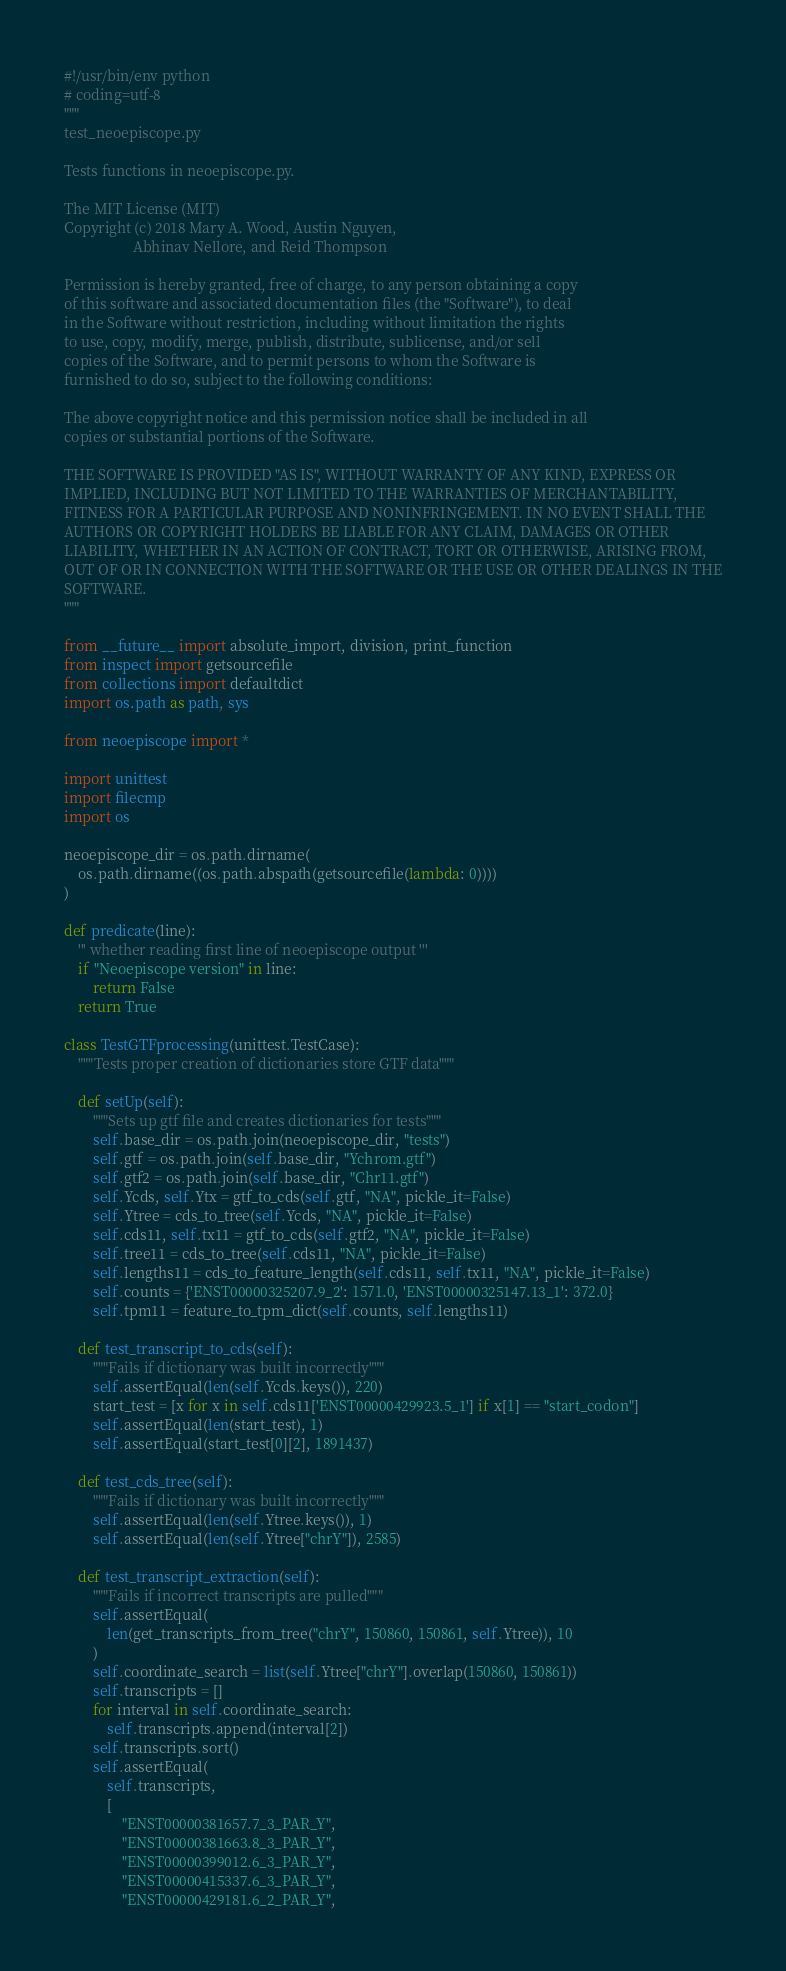Convert code to text. <code><loc_0><loc_0><loc_500><loc_500><_Python_>#!/usr/bin/env python
# coding=utf-8
"""
test_neoepiscope.py

Tests functions in neoepiscope.py.

The MIT License (MIT)
Copyright (c) 2018 Mary A. Wood, Austin Nguyen,
                   Abhinav Nellore, and Reid Thompson

Permission is hereby granted, free of charge, to any person obtaining a copy
of this software and associated documentation files (the "Software"), to deal
in the Software without restriction, including without limitation the rights
to use, copy, modify, merge, publish, distribute, sublicense, and/or sell
copies of the Software, and to permit persons to whom the Software is
furnished to do so, subject to the following conditions:

The above copyright notice and this permission notice shall be included in all
copies or substantial portions of the Software.

THE SOFTWARE IS PROVIDED "AS IS", WITHOUT WARRANTY OF ANY KIND, EXPRESS OR
IMPLIED, INCLUDING BUT NOT LIMITED TO THE WARRANTIES OF MERCHANTABILITY,
FITNESS FOR A PARTICULAR PURPOSE AND NONINFRINGEMENT. IN NO EVENT SHALL THE
AUTHORS OR COPYRIGHT HOLDERS BE LIABLE FOR ANY CLAIM, DAMAGES OR OTHER
LIABILITY, WHETHER IN AN ACTION OF CONTRACT, TORT OR OTHERWISE, ARISING FROM,
OUT OF OR IN CONNECTION WITH THE SOFTWARE OR THE USE OR OTHER DEALINGS IN THE
SOFTWARE.
"""

from __future__ import absolute_import, division, print_function
from inspect import getsourcefile
from collections import defaultdict
import os.path as path, sys

from neoepiscope import *

import unittest
import filecmp
import os

neoepiscope_dir = os.path.dirname(
    os.path.dirname((os.path.abspath(getsourcefile(lambda: 0))))
)

def predicate(line):
    ''' whether reading first line of neoepiscope output '''
    if "Neoepiscope version" in line:
        return False
    return True

class TestGTFprocessing(unittest.TestCase):
    """Tests proper creation of dictionaries store GTF data"""

    def setUp(self):
        """Sets up gtf file and creates dictionaries for tests"""
        self.base_dir = os.path.join(neoepiscope_dir, "tests")
        self.gtf = os.path.join(self.base_dir, "Ychrom.gtf")
        self.gtf2 = os.path.join(self.base_dir, "Chr11.gtf")
        self.Ycds, self.Ytx = gtf_to_cds(self.gtf, "NA", pickle_it=False)
        self.Ytree = cds_to_tree(self.Ycds, "NA", pickle_it=False)
        self.cds11, self.tx11 = gtf_to_cds(self.gtf2, "NA", pickle_it=False)
        self.tree11 = cds_to_tree(self.cds11, "NA", pickle_it=False)
        self.lengths11 = cds_to_feature_length(self.cds11, self.tx11, "NA", pickle_it=False)
        self.counts = {'ENST00000325207.9_2': 1571.0, 'ENST00000325147.13_1': 372.0}
        self.tpm11 = feature_to_tpm_dict(self.counts, self.lengths11)

    def test_transcript_to_cds(self):
        """Fails if dictionary was built incorrectly"""
        self.assertEqual(len(self.Ycds.keys()), 220)
        start_test = [x for x in self.cds11['ENST00000429923.5_1'] if x[1] == "start_codon"]
        self.assertEqual(len(start_test), 1)
        self.assertEqual(start_test[0][2], 1891437)

    def test_cds_tree(self):
        """Fails if dictionary was built incorrectly"""
        self.assertEqual(len(self.Ytree.keys()), 1)
        self.assertEqual(len(self.Ytree["chrY"]), 2585)

    def test_transcript_extraction(self):
        """Fails if incorrect transcripts are pulled"""
        self.assertEqual(
            len(get_transcripts_from_tree("chrY", 150860, 150861, self.Ytree)), 10
        )
        self.coordinate_search = list(self.Ytree["chrY"].overlap(150860, 150861))
        self.transcripts = []
        for interval in self.coordinate_search:
            self.transcripts.append(interval[2])
        self.transcripts.sort()
        self.assertEqual(
            self.transcripts,
            [
                "ENST00000381657.7_3_PAR_Y",
                "ENST00000381663.8_3_PAR_Y",
                "ENST00000399012.6_3_PAR_Y",
                "ENST00000415337.6_3_PAR_Y",
                "ENST00000429181.6_2_PAR_Y",</code> 